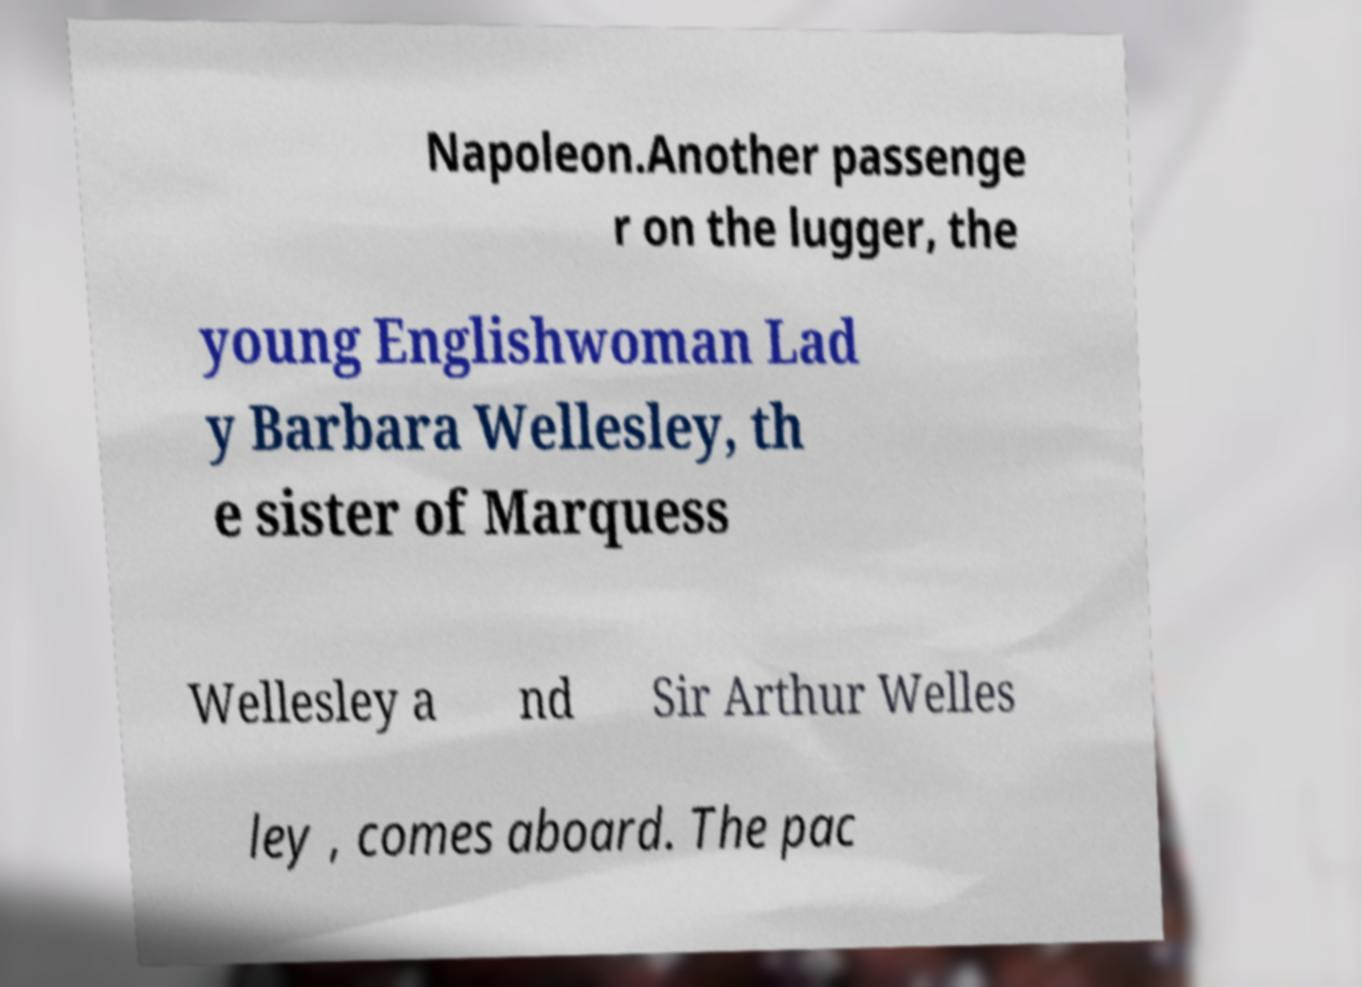Can you accurately transcribe the text from the provided image for me? Napoleon.Another passenge r on the lugger, the young Englishwoman Lad y Barbara Wellesley, th e sister of Marquess Wellesley a nd Sir Arthur Welles ley , comes aboard. The pac 